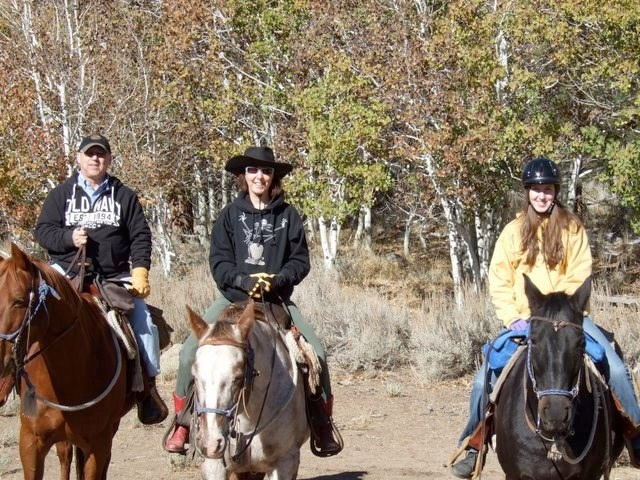Describe the objects in this image and their specific colors. I can see horse in tan, black, maroon, and brown tones, people in tan, black, gray, and darkgray tones, horse in tan, black, gray, and darkgray tones, horse in tan, gray, white, and maroon tones, and people in tan, black, gray, lightgray, and darkgray tones in this image. 